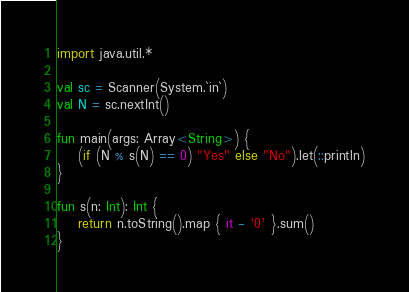Convert code to text. <code><loc_0><loc_0><loc_500><loc_500><_Kotlin_>import java.util.*

val sc = Scanner(System.`in`)
val N = sc.nextInt()

fun main(args: Array<String>) {
    (if (N % s(N) == 0) "Yes" else "No").let(::println)
}

fun s(n: Int): Int {
    return n.toString().map { it - '0' }.sum()
}
</code> 